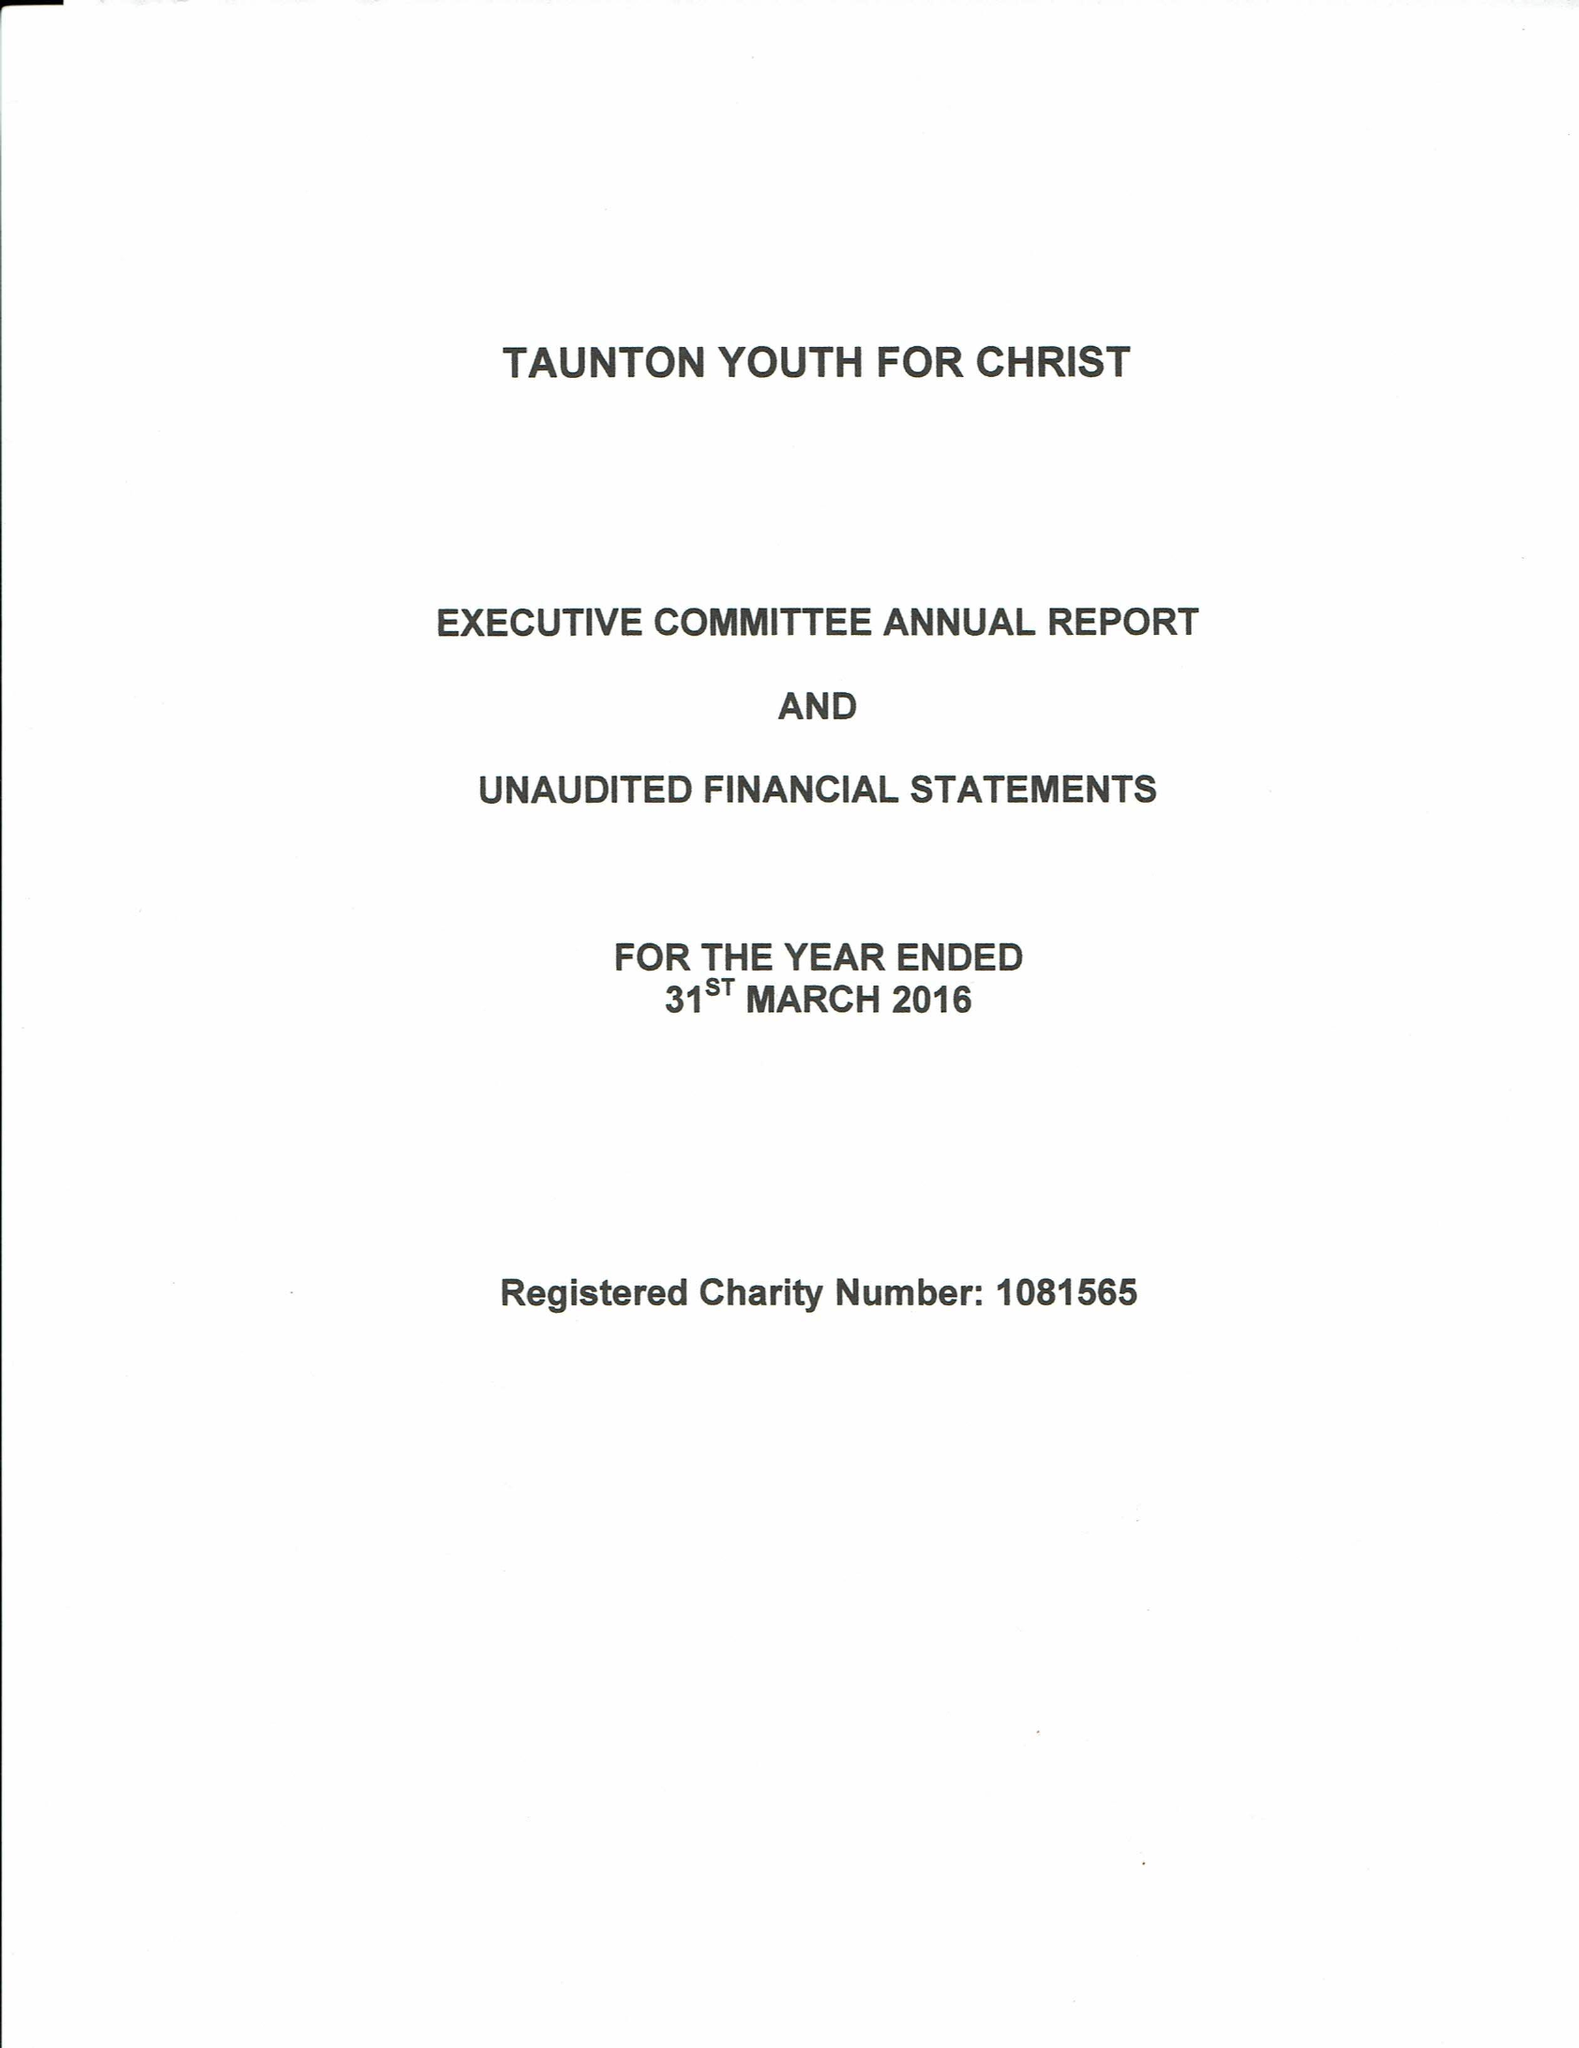What is the value for the income_annually_in_british_pounds?
Answer the question using a single word or phrase. 27909.00 